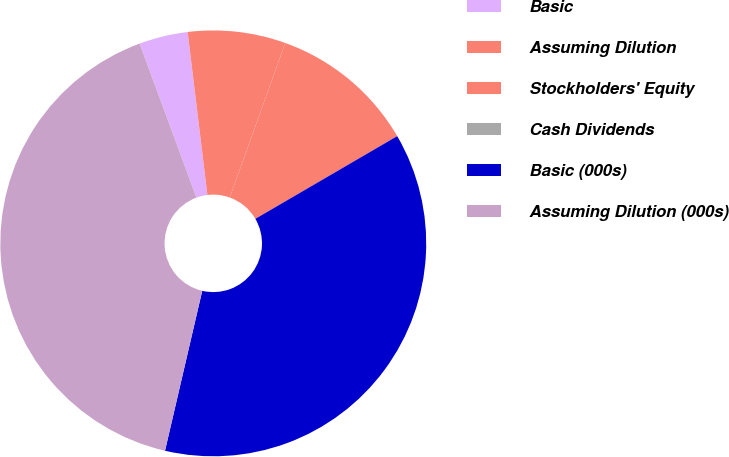<chart> <loc_0><loc_0><loc_500><loc_500><pie_chart><fcel>Basic<fcel>Assuming Dilution<fcel>Stockholders' Equity<fcel>Cash Dividends<fcel>Basic (000s)<fcel>Assuming Dilution (000s)<nl><fcel>3.7%<fcel>7.41%<fcel>11.11%<fcel>0.0%<fcel>37.04%<fcel>40.74%<nl></chart> 